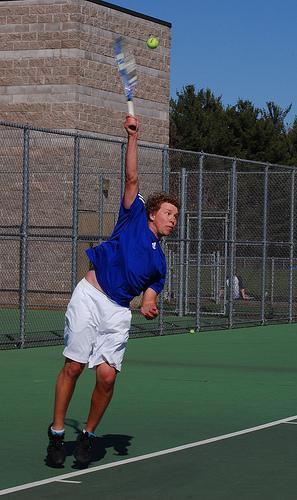How many people are hitting the ball?
Give a very brief answer. 1. How many players are wearing a red shirt?
Give a very brief answer. 0. How many people are sitting down?
Give a very brief answer. 1. 